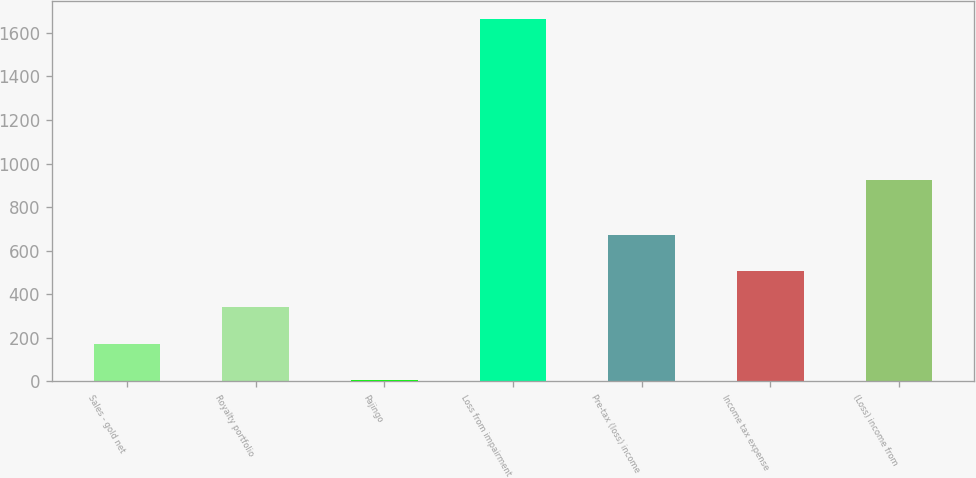Convert chart. <chart><loc_0><loc_0><loc_500><loc_500><bar_chart><fcel>Sales - gold net<fcel>Royalty portfolio<fcel>Pajingo<fcel>Loss from impairment<fcel>Pre-tax (loss) income<fcel>Income tax expense<fcel>(Loss) income from<nl><fcel>173.7<fcel>339.4<fcel>8<fcel>1665<fcel>670.8<fcel>505.1<fcel>923<nl></chart> 